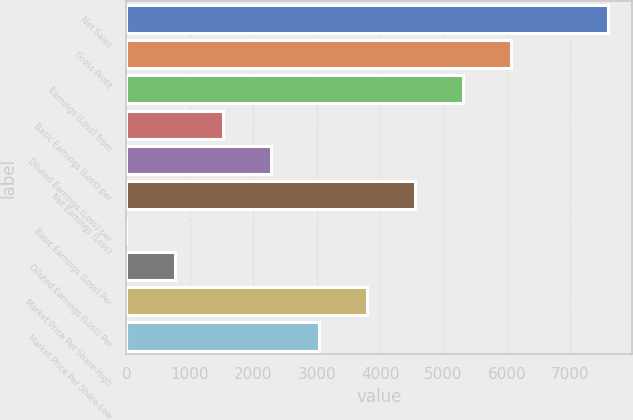Convert chart. <chart><loc_0><loc_0><loc_500><loc_500><bar_chart><fcel>Net Sales<fcel>Gross Profit<fcel>Earnings (Loss) from<fcel>Basic Earnings (Loss) per<fcel>Diluted Earnings (Loss) per<fcel>Net Earnings (Loss)<fcel>Basic Earnings (Loss) Per<fcel>Diluted Earnings (Loss) Per<fcel>Market Price Per Share-High<fcel>Market Price Per Share-Low<nl><fcel>7589<fcel>6071.28<fcel>5312.43<fcel>1518.18<fcel>2277.03<fcel>4553.58<fcel>0.48<fcel>759.33<fcel>3794.73<fcel>3035.88<nl></chart> 